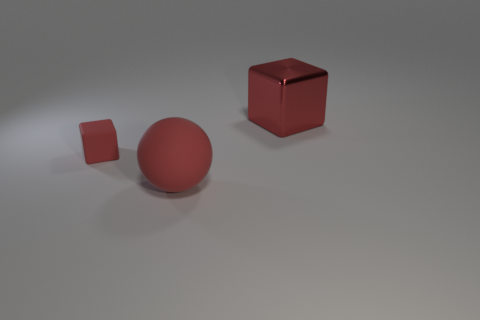Does the rubber block have the same size as the red shiny cube?
Ensure brevity in your answer.  No. Is the number of red things in front of the sphere the same as the number of red rubber spheres right of the small thing?
Provide a succinct answer. No. There is a red thing behind the tiny object; what shape is it?
Offer a very short reply. Cube. There is a metallic object that is the same size as the red sphere; what is its shape?
Your answer should be very brief. Cube. What is the color of the thing behind the red cube that is to the left of the matte thing in front of the tiny matte cube?
Ensure brevity in your answer.  Red. Is the shape of the small red thing the same as the large red metallic thing?
Provide a succinct answer. Yes. Is the number of shiny objects that are behind the tiny block the same as the number of red spheres?
Provide a short and direct response. Yes. What number of other things are the same material as the large red ball?
Make the answer very short. 1. Does the red thing behind the small red rubber object have the same size as the red thing that is in front of the tiny thing?
Provide a succinct answer. Yes. How many objects are either red rubber objects right of the small rubber block or large objects to the left of the big shiny thing?
Offer a very short reply. 1. 